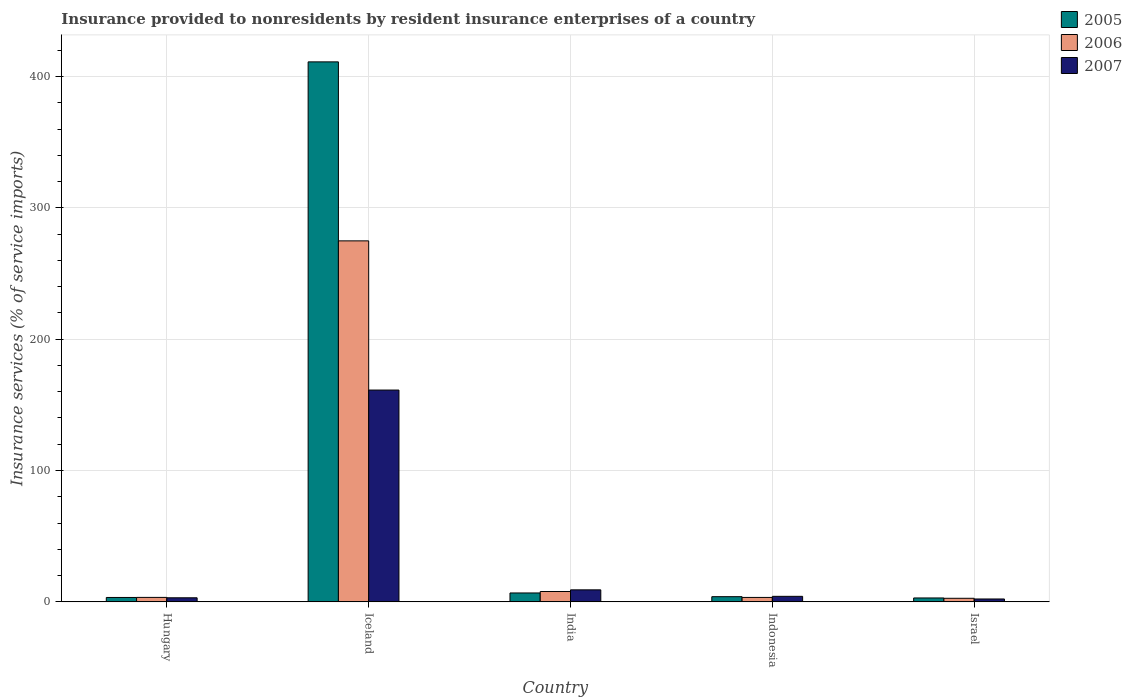How many different coloured bars are there?
Your response must be concise. 3. How many groups of bars are there?
Your response must be concise. 5. How many bars are there on the 1st tick from the left?
Offer a terse response. 3. What is the label of the 1st group of bars from the left?
Give a very brief answer. Hungary. What is the insurance provided to nonresidents in 2007 in Hungary?
Ensure brevity in your answer.  3.11. Across all countries, what is the maximum insurance provided to nonresidents in 2006?
Provide a succinct answer. 274.86. Across all countries, what is the minimum insurance provided to nonresidents in 2006?
Make the answer very short. 2.73. What is the total insurance provided to nonresidents in 2007 in the graph?
Keep it short and to the point. 179.97. What is the difference between the insurance provided to nonresidents in 2005 in Iceland and that in Indonesia?
Provide a short and direct response. 407.18. What is the difference between the insurance provided to nonresidents in 2005 in Israel and the insurance provided to nonresidents in 2007 in Indonesia?
Ensure brevity in your answer.  -1.24. What is the average insurance provided to nonresidents in 2006 per country?
Keep it short and to the point. 58.46. What is the difference between the insurance provided to nonresidents of/in 2006 and insurance provided to nonresidents of/in 2007 in Hungary?
Offer a very short reply. 0.29. What is the ratio of the insurance provided to nonresidents in 2005 in Hungary to that in Israel?
Your response must be concise. 1.13. Is the insurance provided to nonresidents in 2005 in India less than that in Indonesia?
Provide a short and direct response. No. Is the difference between the insurance provided to nonresidents in 2006 in Hungary and Israel greater than the difference between the insurance provided to nonresidents in 2007 in Hungary and Israel?
Provide a succinct answer. No. What is the difference between the highest and the second highest insurance provided to nonresidents in 2006?
Give a very brief answer. 271.46. What is the difference between the highest and the lowest insurance provided to nonresidents in 2007?
Your response must be concise. 159.07. In how many countries, is the insurance provided to nonresidents in 2007 greater than the average insurance provided to nonresidents in 2007 taken over all countries?
Ensure brevity in your answer.  1. What does the 2nd bar from the right in Hungary represents?
Your answer should be very brief. 2006. How many bars are there?
Provide a succinct answer. 15. What is the title of the graph?
Ensure brevity in your answer.  Insurance provided to nonresidents by resident insurance enterprises of a country. Does "1966" appear as one of the legend labels in the graph?
Provide a short and direct response. No. What is the label or title of the X-axis?
Offer a terse response. Country. What is the label or title of the Y-axis?
Your answer should be very brief. Insurance services (% of service imports). What is the Insurance services (% of service imports) of 2005 in Hungary?
Provide a succinct answer. 3.36. What is the Insurance services (% of service imports) of 2006 in Hungary?
Your answer should be very brief. 3.4. What is the Insurance services (% of service imports) of 2007 in Hungary?
Your response must be concise. 3.11. What is the Insurance services (% of service imports) of 2005 in Iceland?
Keep it short and to the point. 411.14. What is the Insurance services (% of service imports) in 2006 in Iceland?
Keep it short and to the point. 274.86. What is the Insurance services (% of service imports) in 2007 in Iceland?
Provide a short and direct response. 161.27. What is the Insurance services (% of service imports) of 2005 in India?
Ensure brevity in your answer.  6.78. What is the Insurance services (% of service imports) of 2006 in India?
Your answer should be compact. 7.9. What is the Insurance services (% of service imports) of 2007 in India?
Offer a terse response. 9.16. What is the Insurance services (% of service imports) of 2005 in Indonesia?
Give a very brief answer. 3.95. What is the Insurance services (% of service imports) in 2006 in Indonesia?
Keep it short and to the point. 3.38. What is the Insurance services (% of service imports) in 2007 in Indonesia?
Make the answer very short. 4.22. What is the Insurance services (% of service imports) in 2005 in Israel?
Offer a very short reply. 2.98. What is the Insurance services (% of service imports) in 2006 in Israel?
Your response must be concise. 2.73. What is the Insurance services (% of service imports) in 2007 in Israel?
Your answer should be very brief. 2.21. Across all countries, what is the maximum Insurance services (% of service imports) of 2005?
Offer a terse response. 411.14. Across all countries, what is the maximum Insurance services (% of service imports) in 2006?
Your response must be concise. 274.86. Across all countries, what is the maximum Insurance services (% of service imports) of 2007?
Offer a terse response. 161.27. Across all countries, what is the minimum Insurance services (% of service imports) in 2005?
Provide a succinct answer. 2.98. Across all countries, what is the minimum Insurance services (% of service imports) in 2006?
Provide a succinct answer. 2.73. Across all countries, what is the minimum Insurance services (% of service imports) in 2007?
Make the answer very short. 2.21. What is the total Insurance services (% of service imports) of 2005 in the graph?
Your answer should be very brief. 428.22. What is the total Insurance services (% of service imports) in 2006 in the graph?
Ensure brevity in your answer.  292.28. What is the total Insurance services (% of service imports) of 2007 in the graph?
Make the answer very short. 179.97. What is the difference between the Insurance services (% of service imports) in 2005 in Hungary and that in Iceland?
Offer a very short reply. -407.77. What is the difference between the Insurance services (% of service imports) of 2006 in Hungary and that in Iceland?
Your answer should be very brief. -271.46. What is the difference between the Insurance services (% of service imports) in 2007 in Hungary and that in Iceland?
Ensure brevity in your answer.  -158.16. What is the difference between the Insurance services (% of service imports) of 2005 in Hungary and that in India?
Offer a very short reply. -3.42. What is the difference between the Insurance services (% of service imports) of 2006 in Hungary and that in India?
Your response must be concise. -4.49. What is the difference between the Insurance services (% of service imports) of 2007 in Hungary and that in India?
Provide a succinct answer. -6.05. What is the difference between the Insurance services (% of service imports) in 2005 in Hungary and that in Indonesia?
Offer a very short reply. -0.59. What is the difference between the Insurance services (% of service imports) of 2006 in Hungary and that in Indonesia?
Keep it short and to the point. 0.02. What is the difference between the Insurance services (% of service imports) in 2007 in Hungary and that in Indonesia?
Make the answer very short. -1.11. What is the difference between the Insurance services (% of service imports) of 2005 in Hungary and that in Israel?
Your answer should be compact. 0.38. What is the difference between the Insurance services (% of service imports) in 2006 in Hungary and that in Israel?
Your answer should be very brief. 0.68. What is the difference between the Insurance services (% of service imports) of 2007 in Hungary and that in Israel?
Your response must be concise. 0.91. What is the difference between the Insurance services (% of service imports) in 2005 in Iceland and that in India?
Provide a short and direct response. 404.35. What is the difference between the Insurance services (% of service imports) of 2006 in Iceland and that in India?
Ensure brevity in your answer.  266.96. What is the difference between the Insurance services (% of service imports) in 2007 in Iceland and that in India?
Your answer should be compact. 152.12. What is the difference between the Insurance services (% of service imports) in 2005 in Iceland and that in Indonesia?
Offer a very short reply. 407.18. What is the difference between the Insurance services (% of service imports) in 2006 in Iceland and that in Indonesia?
Ensure brevity in your answer.  271.48. What is the difference between the Insurance services (% of service imports) of 2007 in Iceland and that in Indonesia?
Keep it short and to the point. 157.05. What is the difference between the Insurance services (% of service imports) in 2005 in Iceland and that in Israel?
Ensure brevity in your answer.  408.15. What is the difference between the Insurance services (% of service imports) of 2006 in Iceland and that in Israel?
Your answer should be compact. 272.13. What is the difference between the Insurance services (% of service imports) of 2007 in Iceland and that in Israel?
Offer a terse response. 159.07. What is the difference between the Insurance services (% of service imports) of 2005 in India and that in Indonesia?
Offer a very short reply. 2.83. What is the difference between the Insurance services (% of service imports) in 2006 in India and that in Indonesia?
Offer a terse response. 4.52. What is the difference between the Insurance services (% of service imports) of 2007 in India and that in Indonesia?
Provide a short and direct response. 4.94. What is the difference between the Insurance services (% of service imports) of 2005 in India and that in Israel?
Ensure brevity in your answer.  3.8. What is the difference between the Insurance services (% of service imports) in 2006 in India and that in Israel?
Offer a very short reply. 5.17. What is the difference between the Insurance services (% of service imports) of 2007 in India and that in Israel?
Provide a short and direct response. 6.95. What is the difference between the Insurance services (% of service imports) of 2006 in Indonesia and that in Israel?
Keep it short and to the point. 0.65. What is the difference between the Insurance services (% of service imports) in 2007 in Indonesia and that in Israel?
Keep it short and to the point. 2.01. What is the difference between the Insurance services (% of service imports) in 2005 in Hungary and the Insurance services (% of service imports) in 2006 in Iceland?
Provide a short and direct response. -271.5. What is the difference between the Insurance services (% of service imports) of 2005 in Hungary and the Insurance services (% of service imports) of 2007 in Iceland?
Offer a very short reply. -157.91. What is the difference between the Insurance services (% of service imports) in 2006 in Hungary and the Insurance services (% of service imports) in 2007 in Iceland?
Provide a short and direct response. -157.87. What is the difference between the Insurance services (% of service imports) in 2005 in Hungary and the Insurance services (% of service imports) in 2006 in India?
Keep it short and to the point. -4.54. What is the difference between the Insurance services (% of service imports) of 2005 in Hungary and the Insurance services (% of service imports) of 2007 in India?
Your answer should be compact. -5.8. What is the difference between the Insurance services (% of service imports) of 2006 in Hungary and the Insurance services (% of service imports) of 2007 in India?
Make the answer very short. -5.75. What is the difference between the Insurance services (% of service imports) of 2005 in Hungary and the Insurance services (% of service imports) of 2006 in Indonesia?
Offer a very short reply. -0.02. What is the difference between the Insurance services (% of service imports) of 2005 in Hungary and the Insurance services (% of service imports) of 2007 in Indonesia?
Give a very brief answer. -0.86. What is the difference between the Insurance services (% of service imports) in 2006 in Hungary and the Insurance services (% of service imports) in 2007 in Indonesia?
Provide a succinct answer. -0.81. What is the difference between the Insurance services (% of service imports) in 2005 in Hungary and the Insurance services (% of service imports) in 2006 in Israel?
Provide a succinct answer. 0.63. What is the difference between the Insurance services (% of service imports) in 2005 in Hungary and the Insurance services (% of service imports) in 2007 in Israel?
Provide a short and direct response. 1.16. What is the difference between the Insurance services (% of service imports) of 2006 in Hungary and the Insurance services (% of service imports) of 2007 in Israel?
Provide a short and direct response. 1.2. What is the difference between the Insurance services (% of service imports) in 2005 in Iceland and the Insurance services (% of service imports) in 2006 in India?
Offer a very short reply. 403.24. What is the difference between the Insurance services (% of service imports) in 2005 in Iceland and the Insurance services (% of service imports) in 2007 in India?
Keep it short and to the point. 401.98. What is the difference between the Insurance services (% of service imports) in 2006 in Iceland and the Insurance services (% of service imports) in 2007 in India?
Your answer should be compact. 265.7. What is the difference between the Insurance services (% of service imports) in 2005 in Iceland and the Insurance services (% of service imports) in 2006 in Indonesia?
Provide a succinct answer. 407.75. What is the difference between the Insurance services (% of service imports) of 2005 in Iceland and the Insurance services (% of service imports) of 2007 in Indonesia?
Provide a succinct answer. 406.92. What is the difference between the Insurance services (% of service imports) of 2006 in Iceland and the Insurance services (% of service imports) of 2007 in Indonesia?
Make the answer very short. 270.64. What is the difference between the Insurance services (% of service imports) of 2005 in Iceland and the Insurance services (% of service imports) of 2006 in Israel?
Provide a succinct answer. 408.41. What is the difference between the Insurance services (% of service imports) in 2005 in Iceland and the Insurance services (% of service imports) in 2007 in Israel?
Offer a terse response. 408.93. What is the difference between the Insurance services (% of service imports) of 2006 in Iceland and the Insurance services (% of service imports) of 2007 in Israel?
Provide a short and direct response. 272.66. What is the difference between the Insurance services (% of service imports) in 2005 in India and the Insurance services (% of service imports) in 2006 in Indonesia?
Keep it short and to the point. 3.4. What is the difference between the Insurance services (% of service imports) in 2005 in India and the Insurance services (% of service imports) in 2007 in Indonesia?
Keep it short and to the point. 2.56. What is the difference between the Insurance services (% of service imports) in 2006 in India and the Insurance services (% of service imports) in 2007 in Indonesia?
Give a very brief answer. 3.68. What is the difference between the Insurance services (% of service imports) in 2005 in India and the Insurance services (% of service imports) in 2006 in Israel?
Your answer should be very brief. 4.05. What is the difference between the Insurance services (% of service imports) of 2005 in India and the Insurance services (% of service imports) of 2007 in Israel?
Give a very brief answer. 4.58. What is the difference between the Insurance services (% of service imports) of 2006 in India and the Insurance services (% of service imports) of 2007 in Israel?
Your response must be concise. 5.69. What is the difference between the Insurance services (% of service imports) of 2005 in Indonesia and the Insurance services (% of service imports) of 2006 in Israel?
Your answer should be compact. 1.22. What is the difference between the Insurance services (% of service imports) in 2005 in Indonesia and the Insurance services (% of service imports) in 2007 in Israel?
Your response must be concise. 1.75. What is the difference between the Insurance services (% of service imports) in 2006 in Indonesia and the Insurance services (% of service imports) in 2007 in Israel?
Keep it short and to the point. 1.18. What is the average Insurance services (% of service imports) in 2005 per country?
Keep it short and to the point. 85.64. What is the average Insurance services (% of service imports) in 2006 per country?
Offer a terse response. 58.46. What is the average Insurance services (% of service imports) in 2007 per country?
Ensure brevity in your answer.  35.99. What is the difference between the Insurance services (% of service imports) in 2005 and Insurance services (% of service imports) in 2006 in Hungary?
Your answer should be compact. -0.04. What is the difference between the Insurance services (% of service imports) of 2005 and Insurance services (% of service imports) of 2007 in Hungary?
Ensure brevity in your answer.  0.25. What is the difference between the Insurance services (% of service imports) in 2006 and Insurance services (% of service imports) in 2007 in Hungary?
Make the answer very short. 0.29. What is the difference between the Insurance services (% of service imports) of 2005 and Insurance services (% of service imports) of 2006 in Iceland?
Offer a very short reply. 136.27. What is the difference between the Insurance services (% of service imports) in 2005 and Insurance services (% of service imports) in 2007 in Iceland?
Offer a terse response. 249.86. What is the difference between the Insurance services (% of service imports) in 2006 and Insurance services (% of service imports) in 2007 in Iceland?
Make the answer very short. 113.59. What is the difference between the Insurance services (% of service imports) in 2005 and Insurance services (% of service imports) in 2006 in India?
Ensure brevity in your answer.  -1.11. What is the difference between the Insurance services (% of service imports) in 2005 and Insurance services (% of service imports) in 2007 in India?
Ensure brevity in your answer.  -2.37. What is the difference between the Insurance services (% of service imports) in 2006 and Insurance services (% of service imports) in 2007 in India?
Ensure brevity in your answer.  -1.26. What is the difference between the Insurance services (% of service imports) of 2005 and Insurance services (% of service imports) of 2006 in Indonesia?
Keep it short and to the point. 0.57. What is the difference between the Insurance services (% of service imports) of 2005 and Insurance services (% of service imports) of 2007 in Indonesia?
Your response must be concise. -0.27. What is the difference between the Insurance services (% of service imports) of 2006 and Insurance services (% of service imports) of 2007 in Indonesia?
Give a very brief answer. -0.84. What is the difference between the Insurance services (% of service imports) of 2005 and Insurance services (% of service imports) of 2006 in Israel?
Provide a short and direct response. 0.25. What is the difference between the Insurance services (% of service imports) in 2005 and Insurance services (% of service imports) in 2007 in Israel?
Offer a very short reply. 0.78. What is the difference between the Insurance services (% of service imports) of 2006 and Insurance services (% of service imports) of 2007 in Israel?
Make the answer very short. 0.52. What is the ratio of the Insurance services (% of service imports) in 2005 in Hungary to that in Iceland?
Offer a terse response. 0.01. What is the ratio of the Insurance services (% of service imports) in 2006 in Hungary to that in Iceland?
Your answer should be very brief. 0.01. What is the ratio of the Insurance services (% of service imports) of 2007 in Hungary to that in Iceland?
Give a very brief answer. 0.02. What is the ratio of the Insurance services (% of service imports) of 2005 in Hungary to that in India?
Offer a very short reply. 0.5. What is the ratio of the Insurance services (% of service imports) of 2006 in Hungary to that in India?
Make the answer very short. 0.43. What is the ratio of the Insurance services (% of service imports) in 2007 in Hungary to that in India?
Provide a succinct answer. 0.34. What is the ratio of the Insurance services (% of service imports) in 2005 in Hungary to that in Indonesia?
Offer a terse response. 0.85. What is the ratio of the Insurance services (% of service imports) of 2007 in Hungary to that in Indonesia?
Offer a terse response. 0.74. What is the ratio of the Insurance services (% of service imports) in 2005 in Hungary to that in Israel?
Keep it short and to the point. 1.13. What is the ratio of the Insurance services (% of service imports) of 2006 in Hungary to that in Israel?
Your response must be concise. 1.25. What is the ratio of the Insurance services (% of service imports) of 2007 in Hungary to that in Israel?
Make the answer very short. 1.41. What is the ratio of the Insurance services (% of service imports) of 2005 in Iceland to that in India?
Give a very brief answer. 60.62. What is the ratio of the Insurance services (% of service imports) in 2006 in Iceland to that in India?
Provide a short and direct response. 34.8. What is the ratio of the Insurance services (% of service imports) in 2007 in Iceland to that in India?
Keep it short and to the point. 17.61. What is the ratio of the Insurance services (% of service imports) in 2005 in Iceland to that in Indonesia?
Offer a very short reply. 104.01. What is the ratio of the Insurance services (% of service imports) in 2006 in Iceland to that in Indonesia?
Keep it short and to the point. 81.27. What is the ratio of the Insurance services (% of service imports) in 2007 in Iceland to that in Indonesia?
Your answer should be compact. 38.23. What is the ratio of the Insurance services (% of service imports) in 2005 in Iceland to that in Israel?
Your answer should be compact. 137.84. What is the ratio of the Insurance services (% of service imports) of 2006 in Iceland to that in Israel?
Make the answer very short. 100.7. What is the ratio of the Insurance services (% of service imports) of 2007 in Iceland to that in Israel?
Your answer should be compact. 73.09. What is the ratio of the Insurance services (% of service imports) of 2005 in India to that in Indonesia?
Offer a terse response. 1.72. What is the ratio of the Insurance services (% of service imports) of 2006 in India to that in Indonesia?
Ensure brevity in your answer.  2.33. What is the ratio of the Insurance services (% of service imports) in 2007 in India to that in Indonesia?
Give a very brief answer. 2.17. What is the ratio of the Insurance services (% of service imports) of 2005 in India to that in Israel?
Ensure brevity in your answer.  2.27. What is the ratio of the Insurance services (% of service imports) in 2006 in India to that in Israel?
Offer a terse response. 2.89. What is the ratio of the Insurance services (% of service imports) of 2007 in India to that in Israel?
Your response must be concise. 4.15. What is the ratio of the Insurance services (% of service imports) in 2005 in Indonesia to that in Israel?
Your response must be concise. 1.33. What is the ratio of the Insurance services (% of service imports) in 2006 in Indonesia to that in Israel?
Keep it short and to the point. 1.24. What is the ratio of the Insurance services (% of service imports) in 2007 in Indonesia to that in Israel?
Your response must be concise. 1.91. What is the difference between the highest and the second highest Insurance services (% of service imports) of 2005?
Give a very brief answer. 404.35. What is the difference between the highest and the second highest Insurance services (% of service imports) in 2006?
Your answer should be very brief. 266.96. What is the difference between the highest and the second highest Insurance services (% of service imports) in 2007?
Provide a succinct answer. 152.12. What is the difference between the highest and the lowest Insurance services (% of service imports) in 2005?
Keep it short and to the point. 408.15. What is the difference between the highest and the lowest Insurance services (% of service imports) of 2006?
Your answer should be very brief. 272.13. What is the difference between the highest and the lowest Insurance services (% of service imports) in 2007?
Provide a short and direct response. 159.07. 